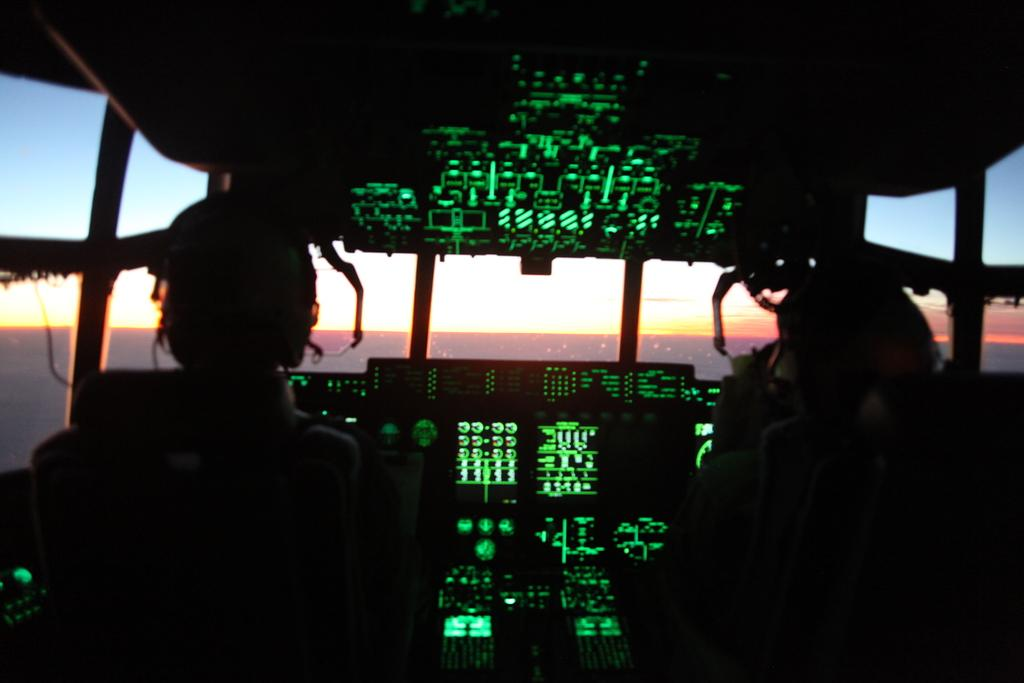What type of location is depicted in the image? The image is an inside view of an airplane. How many people are visible in the image? There are two persons sitting on the seats. What are the persons doing in the image? A: The persons are operating something, which could be related to the airplane's controls or entertainment system. What can be seen in the background of the image? There is sky visible in the background of the image. What type of coat is the person wearing in the image? There is no coat visible in the image, as the persons are inside an airplane and not dressed for cold weather. 